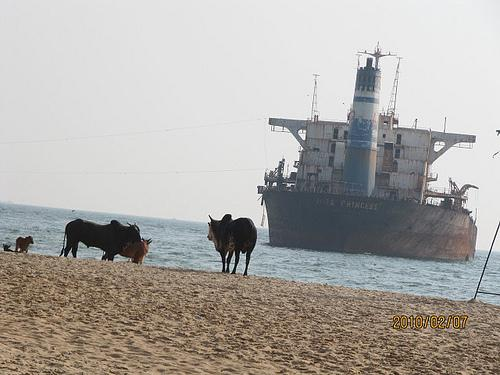Question: what is this a pic of?
Choices:
A. A boat near the beach.
B. A ship.
C. A canoe.
D. A paddleboat.
Answer with the letter. Answer: A Question: what color is the ground?
Choices:
A. Teal.
B. Purple.
C. Tan.
D. Neon.
Answer with the letter. Answer: C 